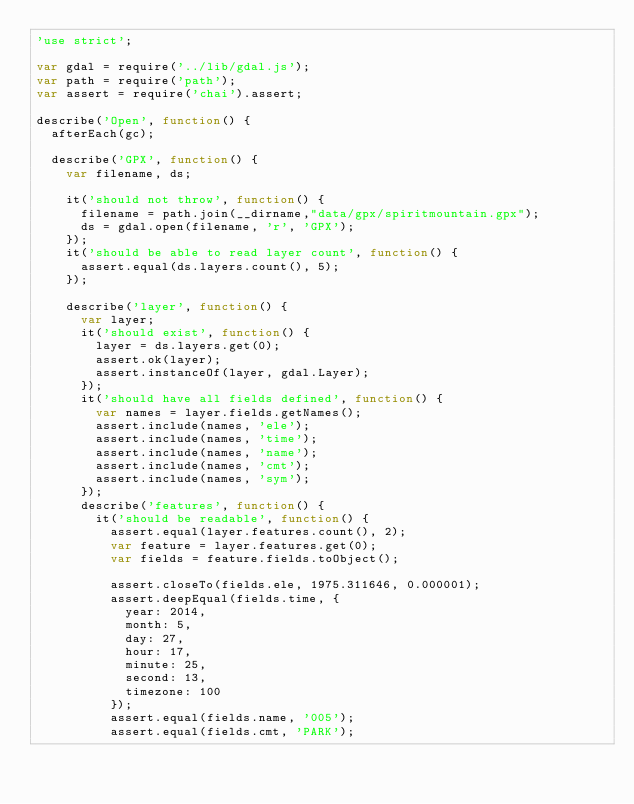<code> <loc_0><loc_0><loc_500><loc_500><_JavaScript_>'use strict';

var gdal = require('../lib/gdal.js');
var path = require('path');
var assert = require('chai').assert;

describe('Open', function() {
	afterEach(gc);

	describe('GPX', function() {
		var filename, ds;

		it('should not throw', function() {
			filename = path.join(__dirname,"data/gpx/spiritmountain.gpx");
			ds = gdal.open(filename, 'r', 'GPX');
		});
		it('should be able to read layer count', function() {
			assert.equal(ds.layers.count(), 5);
		});

		describe('layer', function() {
			var layer;
			it('should exist', function() {
				layer = ds.layers.get(0);
				assert.ok(layer);
				assert.instanceOf(layer, gdal.Layer);
			});
			it('should have all fields defined', function() {
				var names = layer.fields.getNames();
				assert.include(names, 'ele');
				assert.include(names, 'time');
				assert.include(names, 'name');
				assert.include(names, 'cmt');
				assert.include(names, 'sym');
			});
			describe('features', function() {
				it('should be readable', function() {
					assert.equal(layer.features.count(), 2);
					var feature = layer.features.get(0);
					var fields = feature.fields.toObject();

					assert.closeTo(fields.ele, 1975.311646, 0.000001);
					assert.deepEqual(fields.time, {
						year: 2014,
						month: 5,
						day: 27,
						hour: 17,
						minute: 25,
						second: 13,
						timezone: 100
					});
					assert.equal(fields.name, '005');
					assert.equal(fields.cmt, 'PARK');</code> 